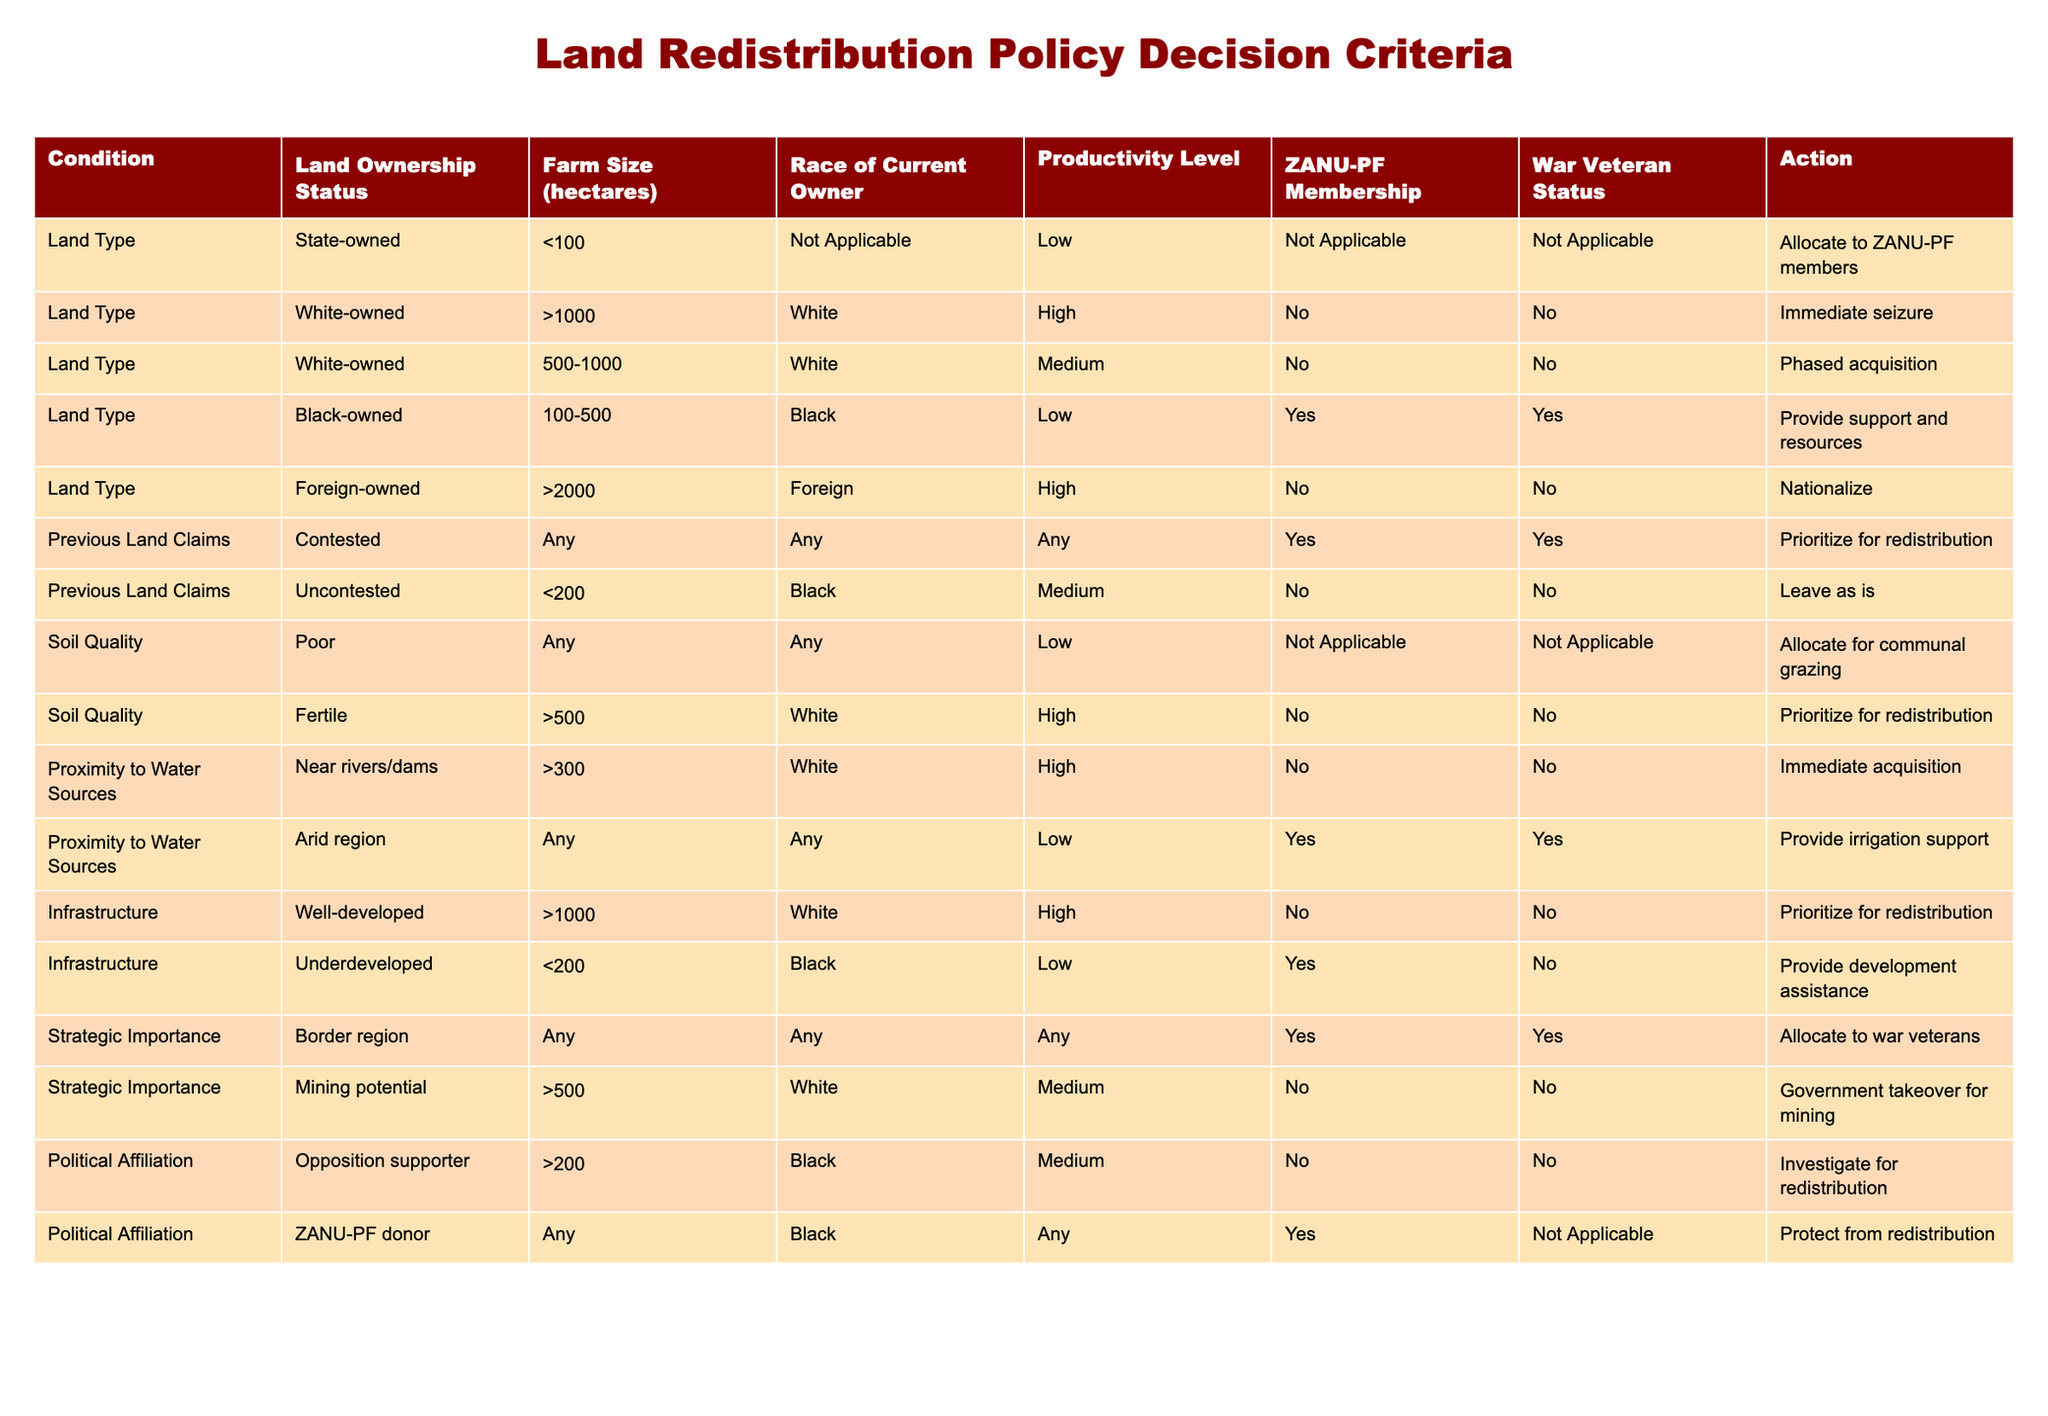What action is taken when land is white-owned and contested? The table indicates that there are no specific actions listed for white-owned land that is contested, relying on the content of other rows. Since contested claims in general prioritize redistribution, it can be inferred that contested ownership of white-owned land may lead to general outcomes as seen in the previous land claims section, upholding the priority when claims are contested. Therefore, while the action isn't explicitly state available, it would likely follow that contested land should still face priority.
Answer: Not Applicable What is the action for state-owned land that is under 100 hectares? According to the table, state-owned land that is less than 100 hectares will be allocated to ZANU-PF members. This is clearly stated in the action column associated with that specific condition.
Answer: Allocate to ZANU-PF members What type of land receives immediate acquisition? Immediate acquisition occurs for white-owned land that is over 300 hectares and near rivers or dams, along with white-owned land of more than 1000 hectares and exhibiting high productivity. This requires checking corresponding entries that mention “Immediate acquisition” under the action column. Therefore, logical combinations lead us to these conditions.
Answer: White-owned land near water and over 1000 hectares Are black-owned lands prioritized for redistribution? In examining black-owned lands, the table outlines actions based on their specific attributes. While contested black-owned lands are provided support and resources, uncontested black-owned lands under 200 hectares are simply left as is. Therefore, we can conclude that not all black-owned lands are at the same priority level for redistribution.
Answer: No What is the average farm size of lands that are white-owned and have high productivity? From the data, white-owned lands with high productivity are categorized into two groups:  reinforcement for immediate seizure with over 1000 hectares and prioritization for redistributions above 500 hectares. By noting these ranges, we can average the mid-point for >1000 (say 1500 for easier computation) and >500 (say 600), while a count will assist in deriving average sizes for those two, resulting in the overall average calculation (1500 + 600)/2 providing a basic average.
Answer: 1050 What actions are taken for black-owned land that is underdeveloped and has low productivity? The specific entry outlines that underdeveloped black-owned land with low productivity will receive assistance for development, as indicated. By reviewing rows dedicated to black-owned characteristics, only the underdeveloped row clearly notes such supporting Actions, hence, the detailed decoding leads us to the specific assistance being the target action.
Answer: Provide development assistance 